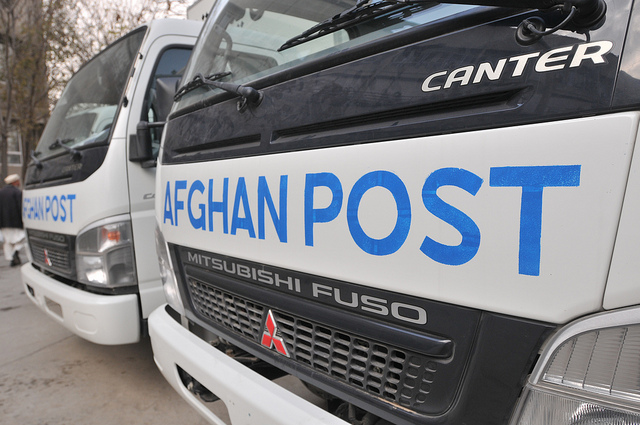Identify the text displayed in this image. CANTER POST AFGHAN FUSO MITSUBISHI 